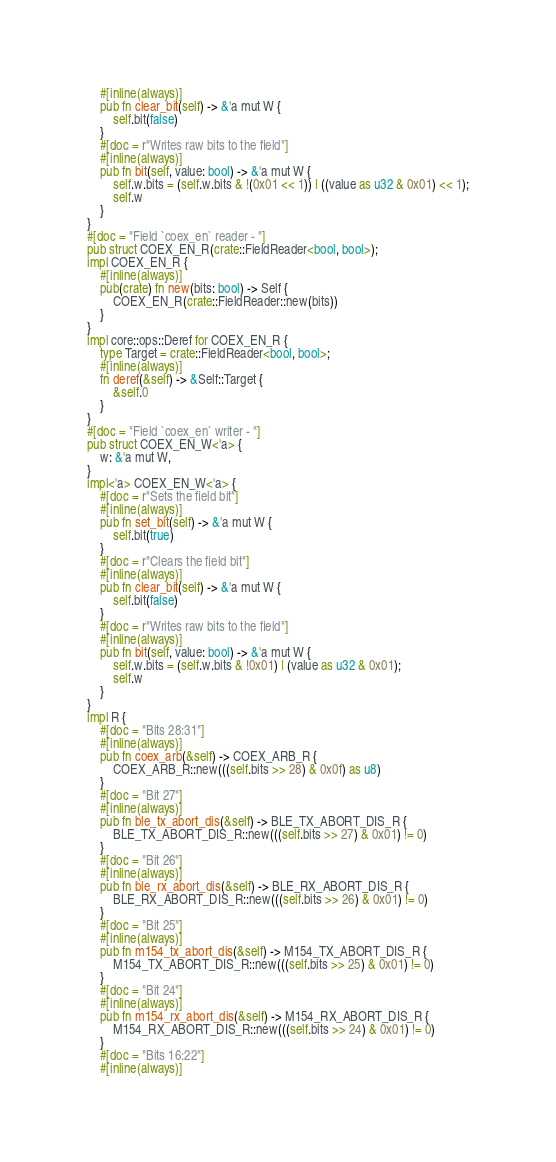<code> <loc_0><loc_0><loc_500><loc_500><_Rust_>    #[inline(always)]
    pub fn clear_bit(self) -> &'a mut W {
        self.bit(false)
    }
    #[doc = r"Writes raw bits to the field"]
    #[inline(always)]
    pub fn bit(self, value: bool) -> &'a mut W {
        self.w.bits = (self.w.bits & !(0x01 << 1)) | ((value as u32 & 0x01) << 1);
        self.w
    }
}
#[doc = "Field `coex_en` reader - "]
pub struct COEX_EN_R(crate::FieldReader<bool, bool>);
impl COEX_EN_R {
    #[inline(always)]
    pub(crate) fn new(bits: bool) -> Self {
        COEX_EN_R(crate::FieldReader::new(bits))
    }
}
impl core::ops::Deref for COEX_EN_R {
    type Target = crate::FieldReader<bool, bool>;
    #[inline(always)]
    fn deref(&self) -> &Self::Target {
        &self.0
    }
}
#[doc = "Field `coex_en` writer - "]
pub struct COEX_EN_W<'a> {
    w: &'a mut W,
}
impl<'a> COEX_EN_W<'a> {
    #[doc = r"Sets the field bit"]
    #[inline(always)]
    pub fn set_bit(self) -> &'a mut W {
        self.bit(true)
    }
    #[doc = r"Clears the field bit"]
    #[inline(always)]
    pub fn clear_bit(self) -> &'a mut W {
        self.bit(false)
    }
    #[doc = r"Writes raw bits to the field"]
    #[inline(always)]
    pub fn bit(self, value: bool) -> &'a mut W {
        self.w.bits = (self.w.bits & !0x01) | (value as u32 & 0x01);
        self.w
    }
}
impl R {
    #[doc = "Bits 28:31"]
    #[inline(always)]
    pub fn coex_arb(&self) -> COEX_ARB_R {
        COEX_ARB_R::new(((self.bits >> 28) & 0x0f) as u8)
    }
    #[doc = "Bit 27"]
    #[inline(always)]
    pub fn ble_tx_abort_dis(&self) -> BLE_TX_ABORT_DIS_R {
        BLE_TX_ABORT_DIS_R::new(((self.bits >> 27) & 0x01) != 0)
    }
    #[doc = "Bit 26"]
    #[inline(always)]
    pub fn ble_rx_abort_dis(&self) -> BLE_RX_ABORT_DIS_R {
        BLE_RX_ABORT_DIS_R::new(((self.bits >> 26) & 0x01) != 0)
    }
    #[doc = "Bit 25"]
    #[inline(always)]
    pub fn m154_tx_abort_dis(&self) -> M154_TX_ABORT_DIS_R {
        M154_TX_ABORT_DIS_R::new(((self.bits >> 25) & 0x01) != 0)
    }
    #[doc = "Bit 24"]
    #[inline(always)]
    pub fn m154_rx_abort_dis(&self) -> M154_RX_ABORT_DIS_R {
        M154_RX_ABORT_DIS_R::new(((self.bits >> 24) & 0x01) != 0)
    }
    #[doc = "Bits 16:22"]
    #[inline(always)]</code> 